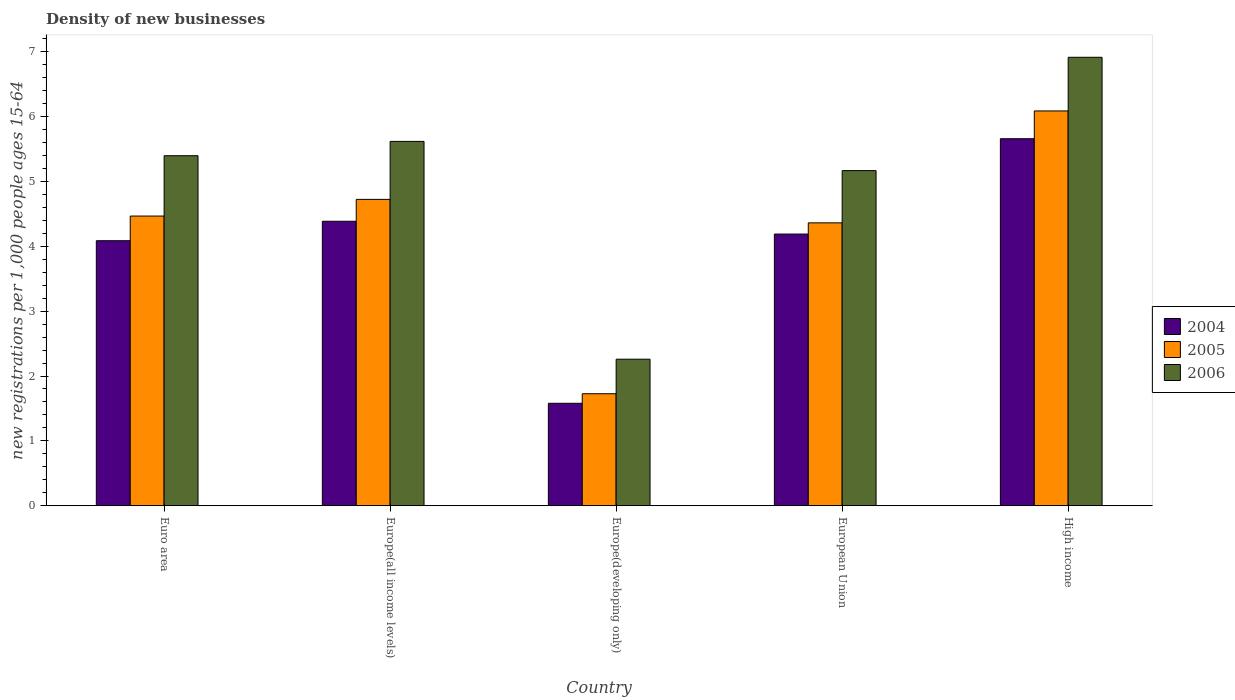How many different coloured bars are there?
Give a very brief answer. 3. How many groups of bars are there?
Provide a succinct answer. 5. Are the number of bars per tick equal to the number of legend labels?
Provide a short and direct response. Yes. Are the number of bars on each tick of the X-axis equal?
Your response must be concise. Yes. How many bars are there on the 3rd tick from the left?
Your response must be concise. 3. What is the label of the 2nd group of bars from the left?
Give a very brief answer. Europe(all income levels). What is the number of new registrations in 2004 in European Union?
Ensure brevity in your answer.  4.19. Across all countries, what is the maximum number of new registrations in 2006?
Give a very brief answer. 6.91. Across all countries, what is the minimum number of new registrations in 2004?
Ensure brevity in your answer.  1.58. In which country was the number of new registrations in 2004 maximum?
Offer a terse response. High income. In which country was the number of new registrations in 2006 minimum?
Offer a very short reply. Europe(developing only). What is the total number of new registrations in 2004 in the graph?
Keep it short and to the point. 19.9. What is the difference between the number of new registrations in 2005 in Europe(developing only) and that in High income?
Your answer should be compact. -4.36. What is the difference between the number of new registrations in 2005 in Europe(developing only) and the number of new registrations in 2004 in High income?
Provide a succinct answer. -3.93. What is the average number of new registrations in 2006 per country?
Give a very brief answer. 5.07. What is the difference between the number of new registrations of/in 2004 and number of new registrations of/in 2005 in High income?
Make the answer very short. -0.43. What is the ratio of the number of new registrations in 2006 in Europe(developing only) to that in European Union?
Provide a short and direct response. 0.44. Is the number of new registrations in 2005 in Europe(all income levels) less than that in European Union?
Provide a succinct answer. No. What is the difference between the highest and the second highest number of new registrations in 2004?
Your answer should be compact. -0.2. What is the difference between the highest and the lowest number of new registrations in 2005?
Your answer should be very brief. 4.36. In how many countries, is the number of new registrations in 2005 greater than the average number of new registrations in 2005 taken over all countries?
Give a very brief answer. 4. Is it the case that in every country, the sum of the number of new registrations in 2005 and number of new registrations in 2004 is greater than the number of new registrations in 2006?
Your answer should be very brief. Yes. How many bars are there?
Provide a short and direct response. 15. Are all the bars in the graph horizontal?
Your answer should be very brief. No. What is the difference between two consecutive major ticks on the Y-axis?
Your answer should be compact. 1. Does the graph contain any zero values?
Your response must be concise. No. Does the graph contain grids?
Give a very brief answer. No. How many legend labels are there?
Offer a terse response. 3. What is the title of the graph?
Your answer should be compact. Density of new businesses. Does "1994" appear as one of the legend labels in the graph?
Provide a succinct answer. No. What is the label or title of the X-axis?
Give a very brief answer. Country. What is the label or title of the Y-axis?
Keep it short and to the point. New registrations per 1,0 people ages 15-64. What is the new registrations per 1,000 people ages 15-64 of 2004 in Euro area?
Keep it short and to the point. 4.09. What is the new registrations per 1,000 people ages 15-64 of 2005 in Euro area?
Make the answer very short. 4.47. What is the new registrations per 1,000 people ages 15-64 of 2006 in Euro area?
Your response must be concise. 5.4. What is the new registrations per 1,000 people ages 15-64 in 2004 in Europe(all income levels)?
Provide a succinct answer. 4.39. What is the new registrations per 1,000 people ages 15-64 of 2005 in Europe(all income levels)?
Ensure brevity in your answer.  4.72. What is the new registrations per 1,000 people ages 15-64 of 2006 in Europe(all income levels)?
Keep it short and to the point. 5.62. What is the new registrations per 1,000 people ages 15-64 in 2004 in Europe(developing only)?
Give a very brief answer. 1.58. What is the new registrations per 1,000 people ages 15-64 in 2005 in Europe(developing only)?
Offer a terse response. 1.73. What is the new registrations per 1,000 people ages 15-64 in 2006 in Europe(developing only)?
Ensure brevity in your answer.  2.26. What is the new registrations per 1,000 people ages 15-64 of 2004 in European Union?
Provide a short and direct response. 4.19. What is the new registrations per 1,000 people ages 15-64 of 2005 in European Union?
Make the answer very short. 4.36. What is the new registrations per 1,000 people ages 15-64 in 2006 in European Union?
Your response must be concise. 5.17. What is the new registrations per 1,000 people ages 15-64 in 2004 in High income?
Offer a very short reply. 5.66. What is the new registrations per 1,000 people ages 15-64 of 2005 in High income?
Provide a short and direct response. 6.09. What is the new registrations per 1,000 people ages 15-64 in 2006 in High income?
Give a very brief answer. 6.91. Across all countries, what is the maximum new registrations per 1,000 people ages 15-64 of 2004?
Make the answer very short. 5.66. Across all countries, what is the maximum new registrations per 1,000 people ages 15-64 of 2005?
Offer a very short reply. 6.09. Across all countries, what is the maximum new registrations per 1,000 people ages 15-64 of 2006?
Keep it short and to the point. 6.91. Across all countries, what is the minimum new registrations per 1,000 people ages 15-64 of 2004?
Ensure brevity in your answer.  1.58. Across all countries, what is the minimum new registrations per 1,000 people ages 15-64 in 2005?
Give a very brief answer. 1.73. Across all countries, what is the minimum new registrations per 1,000 people ages 15-64 in 2006?
Offer a terse response. 2.26. What is the total new registrations per 1,000 people ages 15-64 in 2004 in the graph?
Ensure brevity in your answer.  19.9. What is the total new registrations per 1,000 people ages 15-64 in 2005 in the graph?
Your response must be concise. 21.37. What is the total new registrations per 1,000 people ages 15-64 of 2006 in the graph?
Make the answer very short. 25.36. What is the difference between the new registrations per 1,000 people ages 15-64 in 2004 in Euro area and that in Europe(all income levels)?
Keep it short and to the point. -0.3. What is the difference between the new registrations per 1,000 people ages 15-64 of 2005 in Euro area and that in Europe(all income levels)?
Your answer should be compact. -0.26. What is the difference between the new registrations per 1,000 people ages 15-64 in 2006 in Euro area and that in Europe(all income levels)?
Make the answer very short. -0.22. What is the difference between the new registrations per 1,000 people ages 15-64 in 2004 in Euro area and that in Europe(developing only)?
Your response must be concise. 2.51. What is the difference between the new registrations per 1,000 people ages 15-64 of 2005 in Euro area and that in Europe(developing only)?
Ensure brevity in your answer.  2.74. What is the difference between the new registrations per 1,000 people ages 15-64 in 2006 in Euro area and that in Europe(developing only)?
Provide a succinct answer. 3.14. What is the difference between the new registrations per 1,000 people ages 15-64 of 2004 in Euro area and that in European Union?
Provide a short and direct response. -0.1. What is the difference between the new registrations per 1,000 people ages 15-64 in 2005 in Euro area and that in European Union?
Make the answer very short. 0.1. What is the difference between the new registrations per 1,000 people ages 15-64 in 2006 in Euro area and that in European Union?
Keep it short and to the point. 0.23. What is the difference between the new registrations per 1,000 people ages 15-64 in 2004 in Euro area and that in High income?
Make the answer very short. -1.57. What is the difference between the new registrations per 1,000 people ages 15-64 of 2005 in Euro area and that in High income?
Ensure brevity in your answer.  -1.62. What is the difference between the new registrations per 1,000 people ages 15-64 of 2006 in Euro area and that in High income?
Provide a short and direct response. -1.52. What is the difference between the new registrations per 1,000 people ages 15-64 in 2004 in Europe(all income levels) and that in Europe(developing only)?
Offer a very short reply. 2.81. What is the difference between the new registrations per 1,000 people ages 15-64 of 2005 in Europe(all income levels) and that in Europe(developing only)?
Give a very brief answer. 3. What is the difference between the new registrations per 1,000 people ages 15-64 in 2006 in Europe(all income levels) and that in Europe(developing only)?
Your response must be concise. 3.36. What is the difference between the new registrations per 1,000 people ages 15-64 in 2004 in Europe(all income levels) and that in European Union?
Provide a short and direct response. 0.2. What is the difference between the new registrations per 1,000 people ages 15-64 of 2005 in Europe(all income levels) and that in European Union?
Your answer should be very brief. 0.36. What is the difference between the new registrations per 1,000 people ages 15-64 in 2006 in Europe(all income levels) and that in European Union?
Your response must be concise. 0.45. What is the difference between the new registrations per 1,000 people ages 15-64 in 2004 in Europe(all income levels) and that in High income?
Provide a succinct answer. -1.27. What is the difference between the new registrations per 1,000 people ages 15-64 in 2005 in Europe(all income levels) and that in High income?
Make the answer very short. -1.36. What is the difference between the new registrations per 1,000 people ages 15-64 of 2006 in Europe(all income levels) and that in High income?
Your answer should be compact. -1.3. What is the difference between the new registrations per 1,000 people ages 15-64 of 2004 in Europe(developing only) and that in European Union?
Give a very brief answer. -2.61. What is the difference between the new registrations per 1,000 people ages 15-64 of 2005 in Europe(developing only) and that in European Union?
Keep it short and to the point. -2.64. What is the difference between the new registrations per 1,000 people ages 15-64 in 2006 in Europe(developing only) and that in European Union?
Your answer should be compact. -2.91. What is the difference between the new registrations per 1,000 people ages 15-64 of 2004 in Europe(developing only) and that in High income?
Your answer should be very brief. -4.08. What is the difference between the new registrations per 1,000 people ages 15-64 of 2005 in Europe(developing only) and that in High income?
Offer a terse response. -4.36. What is the difference between the new registrations per 1,000 people ages 15-64 in 2006 in Europe(developing only) and that in High income?
Your answer should be very brief. -4.66. What is the difference between the new registrations per 1,000 people ages 15-64 in 2004 in European Union and that in High income?
Your answer should be compact. -1.47. What is the difference between the new registrations per 1,000 people ages 15-64 in 2005 in European Union and that in High income?
Offer a terse response. -1.73. What is the difference between the new registrations per 1,000 people ages 15-64 in 2006 in European Union and that in High income?
Keep it short and to the point. -1.75. What is the difference between the new registrations per 1,000 people ages 15-64 of 2004 in Euro area and the new registrations per 1,000 people ages 15-64 of 2005 in Europe(all income levels)?
Keep it short and to the point. -0.64. What is the difference between the new registrations per 1,000 people ages 15-64 of 2004 in Euro area and the new registrations per 1,000 people ages 15-64 of 2006 in Europe(all income levels)?
Keep it short and to the point. -1.53. What is the difference between the new registrations per 1,000 people ages 15-64 of 2005 in Euro area and the new registrations per 1,000 people ages 15-64 of 2006 in Europe(all income levels)?
Make the answer very short. -1.15. What is the difference between the new registrations per 1,000 people ages 15-64 of 2004 in Euro area and the new registrations per 1,000 people ages 15-64 of 2005 in Europe(developing only)?
Your answer should be very brief. 2.36. What is the difference between the new registrations per 1,000 people ages 15-64 in 2004 in Euro area and the new registrations per 1,000 people ages 15-64 in 2006 in Europe(developing only)?
Your answer should be very brief. 1.83. What is the difference between the new registrations per 1,000 people ages 15-64 in 2005 in Euro area and the new registrations per 1,000 people ages 15-64 in 2006 in Europe(developing only)?
Your answer should be very brief. 2.21. What is the difference between the new registrations per 1,000 people ages 15-64 in 2004 in Euro area and the new registrations per 1,000 people ages 15-64 in 2005 in European Union?
Your answer should be very brief. -0.28. What is the difference between the new registrations per 1,000 people ages 15-64 in 2004 in Euro area and the new registrations per 1,000 people ages 15-64 in 2006 in European Union?
Give a very brief answer. -1.08. What is the difference between the new registrations per 1,000 people ages 15-64 in 2005 in Euro area and the new registrations per 1,000 people ages 15-64 in 2006 in European Union?
Your answer should be very brief. -0.7. What is the difference between the new registrations per 1,000 people ages 15-64 in 2004 in Euro area and the new registrations per 1,000 people ages 15-64 in 2005 in High income?
Keep it short and to the point. -2. What is the difference between the new registrations per 1,000 people ages 15-64 in 2004 in Euro area and the new registrations per 1,000 people ages 15-64 in 2006 in High income?
Ensure brevity in your answer.  -2.83. What is the difference between the new registrations per 1,000 people ages 15-64 in 2005 in Euro area and the new registrations per 1,000 people ages 15-64 in 2006 in High income?
Your response must be concise. -2.45. What is the difference between the new registrations per 1,000 people ages 15-64 of 2004 in Europe(all income levels) and the new registrations per 1,000 people ages 15-64 of 2005 in Europe(developing only)?
Provide a succinct answer. 2.66. What is the difference between the new registrations per 1,000 people ages 15-64 of 2004 in Europe(all income levels) and the new registrations per 1,000 people ages 15-64 of 2006 in Europe(developing only)?
Your response must be concise. 2.13. What is the difference between the new registrations per 1,000 people ages 15-64 of 2005 in Europe(all income levels) and the new registrations per 1,000 people ages 15-64 of 2006 in Europe(developing only)?
Give a very brief answer. 2.46. What is the difference between the new registrations per 1,000 people ages 15-64 in 2004 in Europe(all income levels) and the new registrations per 1,000 people ages 15-64 in 2005 in European Union?
Your answer should be compact. 0.02. What is the difference between the new registrations per 1,000 people ages 15-64 of 2004 in Europe(all income levels) and the new registrations per 1,000 people ages 15-64 of 2006 in European Union?
Your answer should be very brief. -0.78. What is the difference between the new registrations per 1,000 people ages 15-64 of 2005 in Europe(all income levels) and the new registrations per 1,000 people ages 15-64 of 2006 in European Union?
Ensure brevity in your answer.  -0.44. What is the difference between the new registrations per 1,000 people ages 15-64 of 2004 in Europe(all income levels) and the new registrations per 1,000 people ages 15-64 of 2005 in High income?
Provide a succinct answer. -1.7. What is the difference between the new registrations per 1,000 people ages 15-64 of 2004 in Europe(all income levels) and the new registrations per 1,000 people ages 15-64 of 2006 in High income?
Provide a succinct answer. -2.53. What is the difference between the new registrations per 1,000 people ages 15-64 of 2005 in Europe(all income levels) and the new registrations per 1,000 people ages 15-64 of 2006 in High income?
Offer a terse response. -2.19. What is the difference between the new registrations per 1,000 people ages 15-64 in 2004 in Europe(developing only) and the new registrations per 1,000 people ages 15-64 in 2005 in European Union?
Ensure brevity in your answer.  -2.78. What is the difference between the new registrations per 1,000 people ages 15-64 of 2004 in Europe(developing only) and the new registrations per 1,000 people ages 15-64 of 2006 in European Union?
Offer a terse response. -3.59. What is the difference between the new registrations per 1,000 people ages 15-64 in 2005 in Europe(developing only) and the new registrations per 1,000 people ages 15-64 in 2006 in European Union?
Provide a short and direct response. -3.44. What is the difference between the new registrations per 1,000 people ages 15-64 in 2004 in Europe(developing only) and the new registrations per 1,000 people ages 15-64 in 2005 in High income?
Your answer should be compact. -4.51. What is the difference between the new registrations per 1,000 people ages 15-64 in 2004 in Europe(developing only) and the new registrations per 1,000 people ages 15-64 in 2006 in High income?
Your answer should be very brief. -5.33. What is the difference between the new registrations per 1,000 people ages 15-64 in 2005 in Europe(developing only) and the new registrations per 1,000 people ages 15-64 in 2006 in High income?
Offer a very short reply. -5.19. What is the difference between the new registrations per 1,000 people ages 15-64 of 2004 in European Union and the new registrations per 1,000 people ages 15-64 of 2005 in High income?
Keep it short and to the point. -1.9. What is the difference between the new registrations per 1,000 people ages 15-64 of 2004 in European Union and the new registrations per 1,000 people ages 15-64 of 2006 in High income?
Provide a succinct answer. -2.73. What is the difference between the new registrations per 1,000 people ages 15-64 of 2005 in European Union and the new registrations per 1,000 people ages 15-64 of 2006 in High income?
Offer a very short reply. -2.55. What is the average new registrations per 1,000 people ages 15-64 in 2004 per country?
Provide a succinct answer. 3.98. What is the average new registrations per 1,000 people ages 15-64 of 2005 per country?
Give a very brief answer. 4.27. What is the average new registrations per 1,000 people ages 15-64 of 2006 per country?
Make the answer very short. 5.07. What is the difference between the new registrations per 1,000 people ages 15-64 of 2004 and new registrations per 1,000 people ages 15-64 of 2005 in Euro area?
Give a very brief answer. -0.38. What is the difference between the new registrations per 1,000 people ages 15-64 in 2004 and new registrations per 1,000 people ages 15-64 in 2006 in Euro area?
Your answer should be compact. -1.31. What is the difference between the new registrations per 1,000 people ages 15-64 of 2005 and new registrations per 1,000 people ages 15-64 of 2006 in Euro area?
Offer a very short reply. -0.93. What is the difference between the new registrations per 1,000 people ages 15-64 in 2004 and new registrations per 1,000 people ages 15-64 in 2005 in Europe(all income levels)?
Offer a very short reply. -0.34. What is the difference between the new registrations per 1,000 people ages 15-64 in 2004 and new registrations per 1,000 people ages 15-64 in 2006 in Europe(all income levels)?
Keep it short and to the point. -1.23. What is the difference between the new registrations per 1,000 people ages 15-64 of 2005 and new registrations per 1,000 people ages 15-64 of 2006 in Europe(all income levels)?
Provide a short and direct response. -0.89. What is the difference between the new registrations per 1,000 people ages 15-64 of 2004 and new registrations per 1,000 people ages 15-64 of 2005 in Europe(developing only)?
Provide a succinct answer. -0.15. What is the difference between the new registrations per 1,000 people ages 15-64 of 2004 and new registrations per 1,000 people ages 15-64 of 2006 in Europe(developing only)?
Provide a short and direct response. -0.68. What is the difference between the new registrations per 1,000 people ages 15-64 of 2005 and new registrations per 1,000 people ages 15-64 of 2006 in Europe(developing only)?
Provide a succinct answer. -0.53. What is the difference between the new registrations per 1,000 people ages 15-64 in 2004 and new registrations per 1,000 people ages 15-64 in 2005 in European Union?
Provide a succinct answer. -0.17. What is the difference between the new registrations per 1,000 people ages 15-64 of 2004 and new registrations per 1,000 people ages 15-64 of 2006 in European Union?
Your response must be concise. -0.98. What is the difference between the new registrations per 1,000 people ages 15-64 in 2005 and new registrations per 1,000 people ages 15-64 in 2006 in European Union?
Keep it short and to the point. -0.81. What is the difference between the new registrations per 1,000 people ages 15-64 of 2004 and new registrations per 1,000 people ages 15-64 of 2005 in High income?
Provide a succinct answer. -0.43. What is the difference between the new registrations per 1,000 people ages 15-64 in 2004 and new registrations per 1,000 people ages 15-64 in 2006 in High income?
Ensure brevity in your answer.  -1.26. What is the difference between the new registrations per 1,000 people ages 15-64 in 2005 and new registrations per 1,000 people ages 15-64 in 2006 in High income?
Provide a succinct answer. -0.83. What is the ratio of the new registrations per 1,000 people ages 15-64 of 2004 in Euro area to that in Europe(all income levels)?
Your response must be concise. 0.93. What is the ratio of the new registrations per 1,000 people ages 15-64 of 2005 in Euro area to that in Europe(all income levels)?
Your answer should be compact. 0.95. What is the ratio of the new registrations per 1,000 people ages 15-64 of 2006 in Euro area to that in Europe(all income levels)?
Give a very brief answer. 0.96. What is the ratio of the new registrations per 1,000 people ages 15-64 in 2004 in Euro area to that in Europe(developing only)?
Make the answer very short. 2.59. What is the ratio of the new registrations per 1,000 people ages 15-64 of 2005 in Euro area to that in Europe(developing only)?
Your answer should be very brief. 2.59. What is the ratio of the new registrations per 1,000 people ages 15-64 of 2006 in Euro area to that in Europe(developing only)?
Offer a very short reply. 2.39. What is the ratio of the new registrations per 1,000 people ages 15-64 of 2004 in Euro area to that in European Union?
Provide a succinct answer. 0.98. What is the ratio of the new registrations per 1,000 people ages 15-64 of 2005 in Euro area to that in European Union?
Your answer should be compact. 1.02. What is the ratio of the new registrations per 1,000 people ages 15-64 of 2006 in Euro area to that in European Union?
Your answer should be very brief. 1.04. What is the ratio of the new registrations per 1,000 people ages 15-64 of 2004 in Euro area to that in High income?
Keep it short and to the point. 0.72. What is the ratio of the new registrations per 1,000 people ages 15-64 in 2005 in Euro area to that in High income?
Offer a terse response. 0.73. What is the ratio of the new registrations per 1,000 people ages 15-64 in 2006 in Euro area to that in High income?
Provide a succinct answer. 0.78. What is the ratio of the new registrations per 1,000 people ages 15-64 in 2004 in Europe(all income levels) to that in Europe(developing only)?
Your answer should be very brief. 2.78. What is the ratio of the new registrations per 1,000 people ages 15-64 in 2005 in Europe(all income levels) to that in Europe(developing only)?
Your response must be concise. 2.74. What is the ratio of the new registrations per 1,000 people ages 15-64 of 2006 in Europe(all income levels) to that in Europe(developing only)?
Your answer should be compact. 2.49. What is the ratio of the new registrations per 1,000 people ages 15-64 of 2004 in Europe(all income levels) to that in European Union?
Give a very brief answer. 1.05. What is the ratio of the new registrations per 1,000 people ages 15-64 of 2005 in Europe(all income levels) to that in European Union?
Make the answer very short. 1.08. What is the ratio of the new registrations per 1,000 people ages 15-64 in 2006 in Europe(all income levels) to that in European Union?
Offer a terse response. 1.09. What is the ratio of the new registrations per 1,000 people ages 15-64 of 2004 in Europe(all income levels) to that in High income?
Ensure brevity in your answer.  0.78. What is the ratio of the new registrations per 1,000 people ages 15-64 in 2005 in Europe(all income levels) to that in High income?
Ensure brevity in your answer.  0.78. What is the ratio of the new registrations per 1,000 people ages 15-64 of 2006 in Europe(all income levels) to that in High income?
Make the answer very short. 0.81. What is the ratio of the new registrations per 1,000 people ages 15-64 of 2004 in Europe(developing only) to that in European Union?
Make the answer very short. 0.38. What is the ratio of the new registrations per 1,000 people ages 15-64 of 2005 in Europe(developing only) to that in European Union?
Offer a terse response. 0.4. What is the ratio of the new registrations per 1,000 people ages 15-64 in 2006 in Europe(developing only) to that in European Union?
Your answer should be very brief. 0.44. What is the ratio of the new registrations per 1,000 people ages 15-64 in 2004 in Europe(developing only) to that in High income?
Offer a very short reply. 0.28. What is the ratio of the new registrations per 1,000 people ages 15-64 in 2005 in Europe(developing only) to that in High income?
Offer a terse response. 0.28. What is the ratio of the new registrations per 1,000 people ages 15-64 in 2006 in Europe(developing only) to that in High income?
Offer a terse response. 0.33. What is the ratio of the new registrations per 1,000 people ages 15-64 of 2004 in European Union to that in High income?
Offer a terse response. 0.74. What is the ratio of the new registrations per 1,000 people ages 15-64 of 2005 in European Union to that in High income?
Keep it short and to the point. 0.72. What is the ratio of the new registrations per 1,000 people ages 15-64 in 2006 in European Union to that in High income?
Make the answer very short. 0.75. What is the difference between the highest and the second highest new registrations per 1,000 people ages 15-64 in 2004?
Give a very brief answer. 1.27. What is the difference between the highest and the second highest new registrations per 1,000 people ages 15-64 in 2005?
Ensure brevity in your answer.  1.36. What is the difference between the highest and the second highest new registrations per 1,000 people ages 15-64 in 2006?
Make the answer very short. 1.3. What is the difference between the highest and the lowest new registrations per 1,000 people ages 15-64 of 2004?
Your response must be concise. 4.08. What is the difference between the highest and the lowest new registrations per 1,000 people ages 15-64 in 2005?
Ensure brevity in your answer.  4.36. What is the difference between the highest and the lowest new registrations per 1,000 people ages 15-64 in 2006?
Your response must be concise. 4.66. 